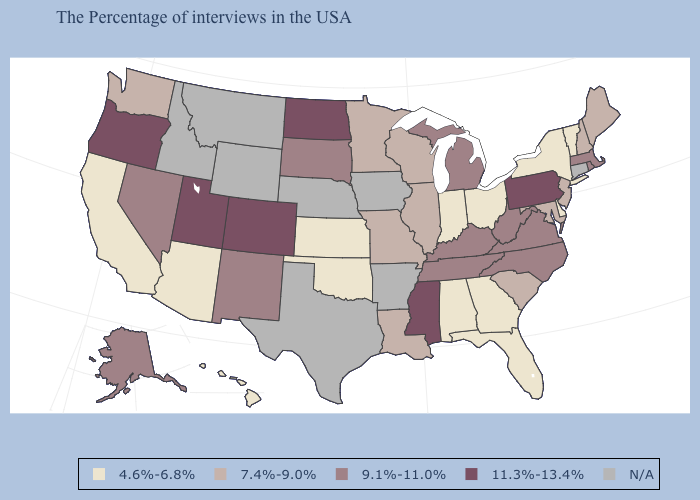What is the value of New Hampshire?
Give a very brief answer. 7.4%-9.0%. Does Oregon have the highest value in the West?
Write a very short answer. Yes. Name the states that have a value in the range 11.3%-13.4%?
Concise answer only. Pennsylvania, Mississippi, North Dakota, Colorado, Utah, Oregon. What is the lowest value in states that border New York?
Concise answer only. 4.6%-6.8%. What is the value of Minnesota?
Keep it brief. 7.4%-9.0%. What is the value of New Jersey?
Short answer required. 7.4%-9.0%. What is the value of Tennessee?
Quick response, please. 9.1%-11.0%. Name the states that have a value in the range N/A?
Short answer required. Connecticut, Arkansas, Iowa, Nebraska, Texas, Wyoming, Montana, Idaho. What is the value of Nebraska?
Short answer required. N/A. Does the first symbol in the legend represent the smallest category?
Write a very short answer. Yes. What is the lowest value in the USA?
Be succinct. 4.6%-6.8%. Does Indiana have the highest value in the USA?
Keep it brief. No. What is the value of North Carolina?
Write a very short answer. 9.1%-11.0%. Does the map have missing data?
Write a very short answer. Yes. 